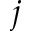<formula> <loc_0><loc_0><loc_500><loc_500>j</formula> 